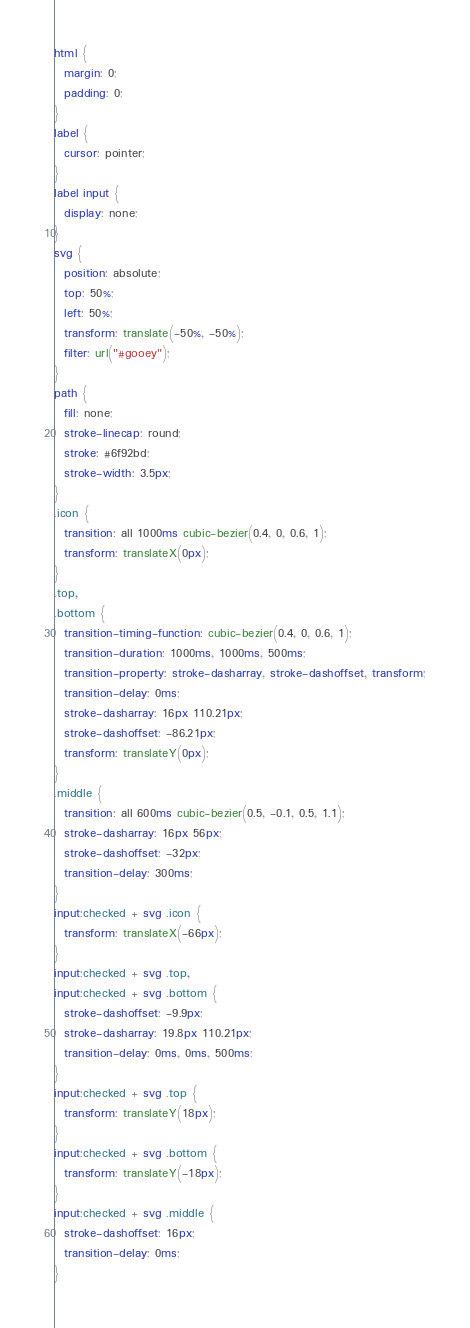<code> <loc_0><loc_0><loc_500><loc_500><_CSS_>html {
  margin: 0;
  padding: 0;
}
label {
  cursor: pointer;
}
label input {
  display: none;
}
svg {
  position: absolute;
  top: 50%;
  left: 50%;
  transform: translate(-50%, -50%);
  filter: url("#gooey");
}
path {
  fill: none;
  stroke-linecap: round;
  stroke: #6f92bd;
  stroke-width: 3.5px;
}
.icon {
  transition: all 1000ms cubic-bezier(0.4, 0, 0.6, 1);
  transform: translateX(0px);
}
.top,
.bottom {
  transition-timing-function: cubic-bezier(0.4, 0, 0.6, 1);
  transition-duration: 1000ms, 1000ms, 500ms;
  transition-property: stroke-dasharray, stroke-dashoffset, transform;
  transition-delay: 0ms;
  stroke-dasharray: 16px 110.21px;
  stroke-dashoffset: -86.21px;
  transform: translateY(0px);
}
.middle {
  transition: all 600ms cubic-bezier(0.5, -0.1, 0.5, 1.1);
  stroke-dasharray: 16px 56px;
  stroke-dashoffset: -32px;
  transition-delay: 300ms;
}
input:checked + svg .icon {
  transform: translateX(-66px);
}
input:checked + svg .top,
input:checked + svg .bottom {
  stroke-dashoffset: -9.9px;
  stroke-dasharray: 19.8px 110.21px;
  transition-delay: 0ms, 0ms, 500ms;
}
input:checked + svg .top {
  transform: translateY(18px);
}
input:checked + svg .bottom {
  transform: translateY(-18px);
}
input:checked + svg .middle {
  stroke-dashoffset: 16px;
  transition-delay: 0ms;
}
</code> 